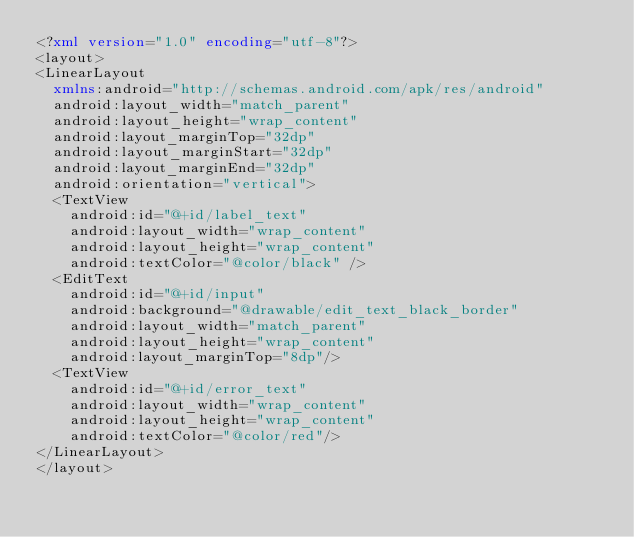Convert code to text. <code><loc_0><loc_0><loc_500><loc_500><_XML_><?xml version="1.0" encoding="utf-8"?>
<layout>
<LinearLayout
  xmlns:android="http://schemas.android.com/apk/res/android"
  android:layout_width="match_parent"
  android:layout_height="wrap_content"
  android:layout_marginTop="32dp"
  android:layout_marginStart="32dp"
  android:layout_marginEnd="32dp"
  android:orientation="vertical">
  <TextView
    android:id="@+id/label_text"
    android:layout_width="wrap_content"
    android:layout_height="wrap_content"
    android:textColor="@color/black" />
  <EditText
    android:id="@+id/input"
    android:background="@drawable/edit_text_black_border"
    android:layout_width="match_parent"
    android:layout_height="wrap_content"
    android:layout_marginTop="8dp"/>
  <TextView
    android:id="@+id/error_text"
    android:layout_width="wrap_content"
    android:layout_height="wrap_content"
    android:textColor="@color/red"/>
</LinearLayout>
</layout>
</code> 